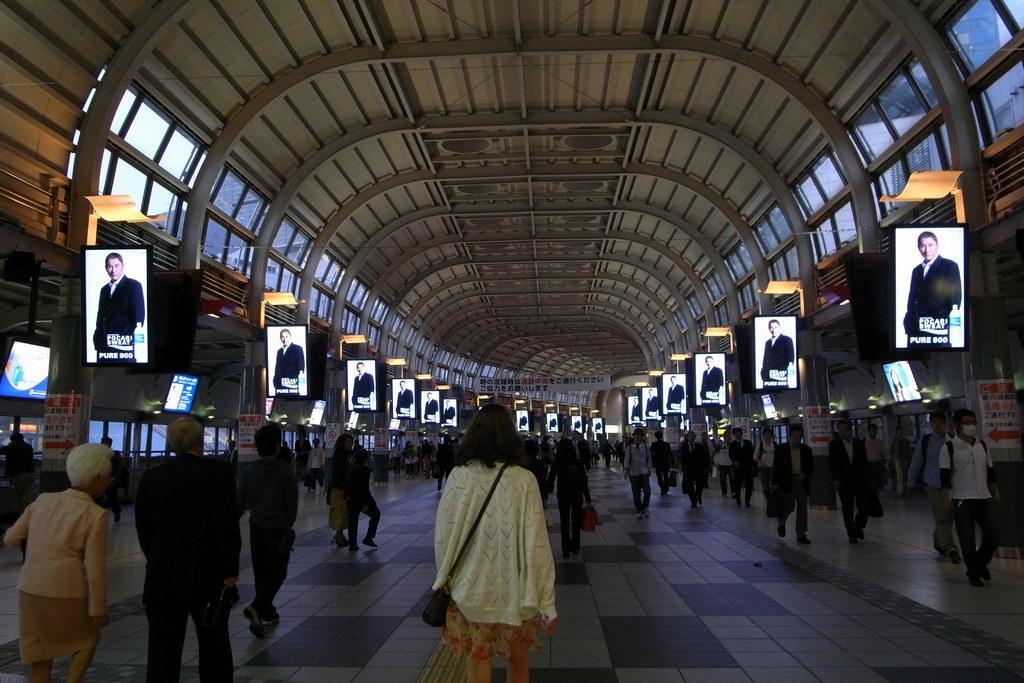How would you summarize this image in a sentence or two? This is an inside view of a shed. At the bottom there are many people walking on the floor. On the right and left side of the image I can see the windows to the walls and there are many boards on which I can see an image of a man. At the top of the image I can see the roof. 